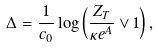<formula> <loc_0><loc_0><loc_500><loc_500>\Delta = \frac { 1 } { c _ { 0 } } \log \left ( \frac { Z _ { T } } { \kappa e ^ { A } } \vee 1 \right ) ,</formula> 